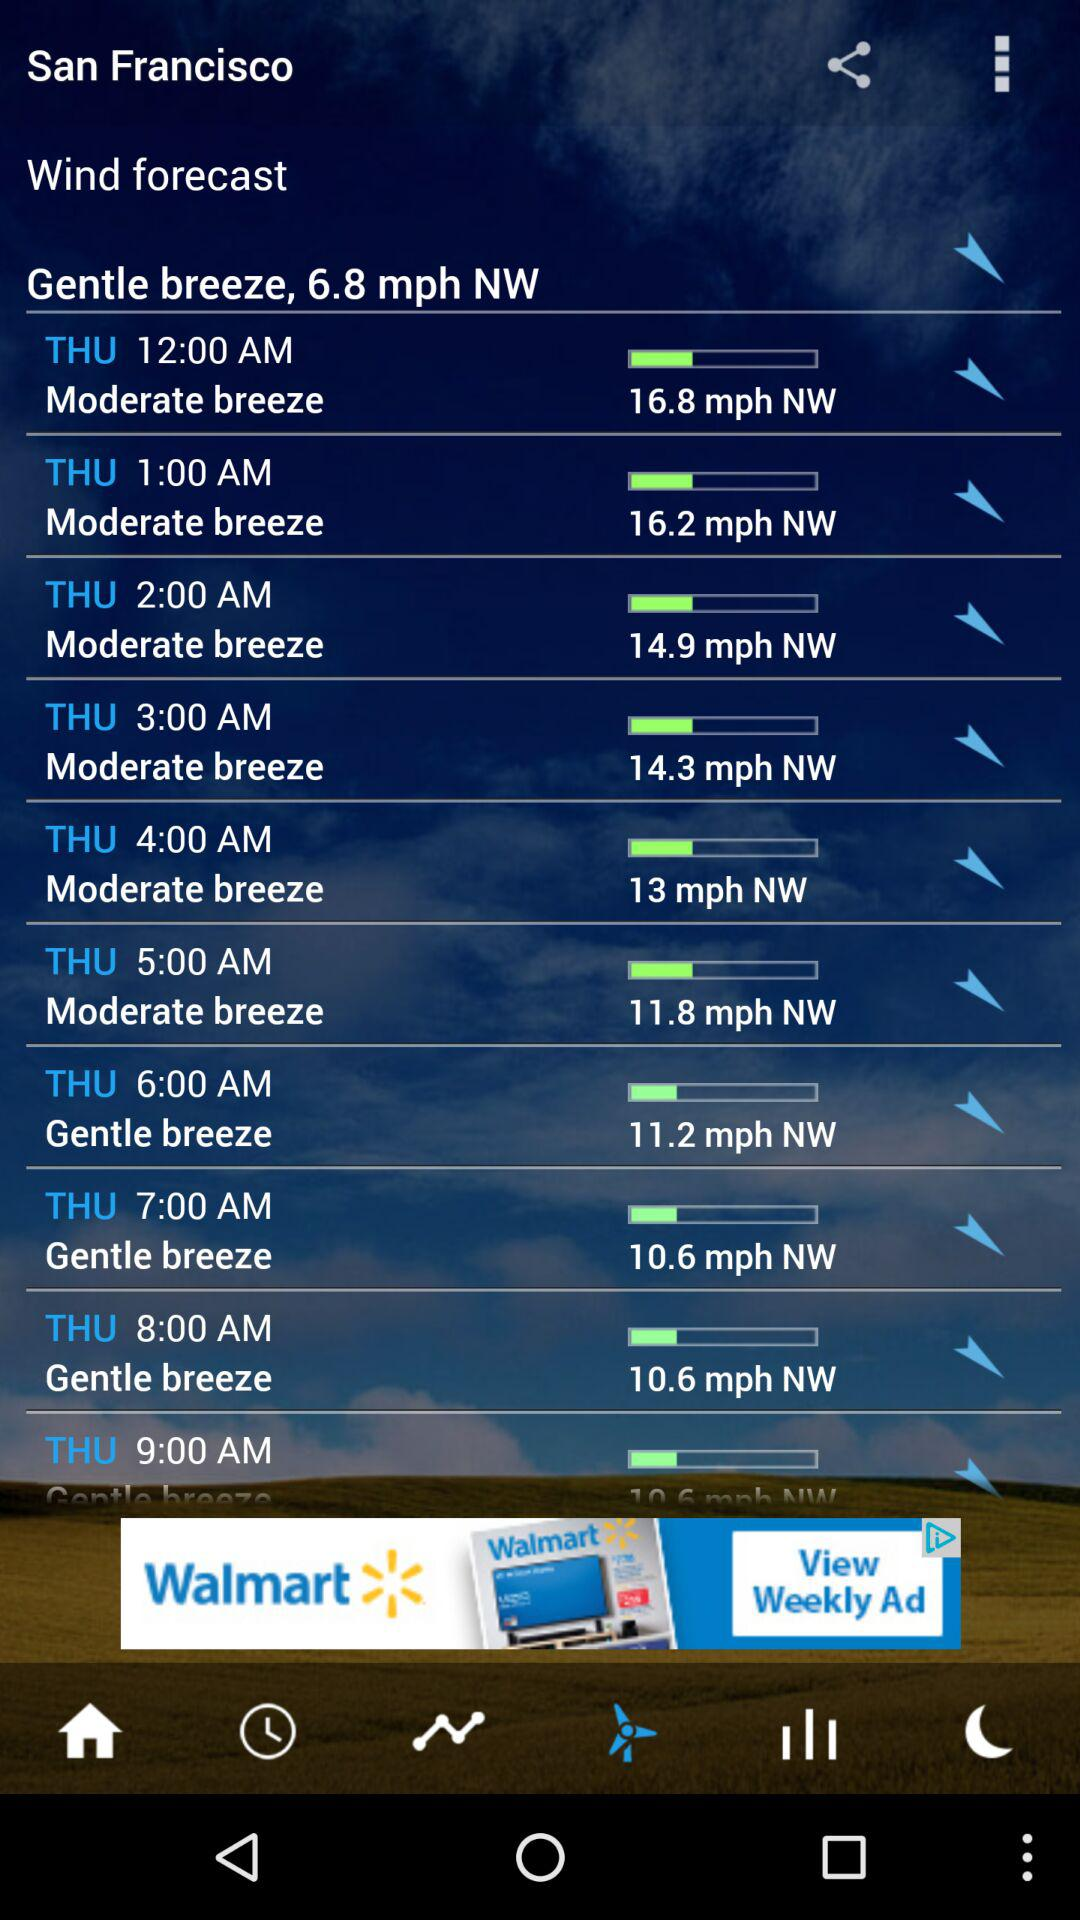What is the mentioned city? The mentioned city is San Francisco. 